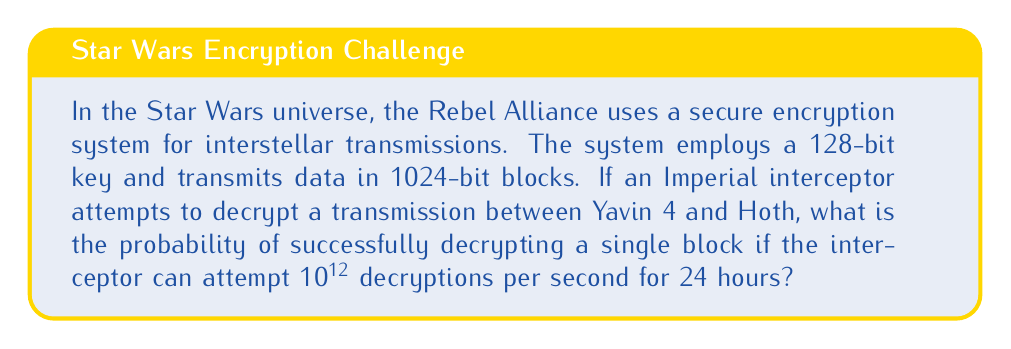What is the answer to this math problem? To solve this problem, we'll follow these steps:

1) First, calculate the total number of possible keys:
   $$ \text{Number of keys} = 2^{128} $$

2) Calculate the number of decryption attempts possible in 24 hours:
   $$ \text{Attempts} = 10^{12} \text{ attempts/second} \times 60 \text{ seconds/minute} \times 60 \text{ minutes/hour} \times 24 \text{ hours} $$
   $$ = 10^{12} \times 60 \times 60 \times 24 = 8.64 \times 10^{16} \text{ attempts} $$

3) The probability of success is the number of attempts divided by the total number of possible keys:
   $$ P(\text{success}) = \frac{\text{Number of attempts}}{\text{Total number of keys}} = \frac{8.64 \times 10^{16}}{2^{128}} $$

4) Simplify:
   $$ P(\text{success}) = \frac{8.64 \times 10^{16}}{3.4028 \times 10^{38}} \approx 2.54 \times 10^{-22} $$

This extremely low probability demonstrates the strength of the 128-bit encryption system, even against a powerful Imperial interceptor. The vast distances between celestial bodies in the Star Wars galaxy, such as Yavin 4 and Hoth, further complicate interception efforts.
Answer: $2.54 \times 10^{-22}$ 